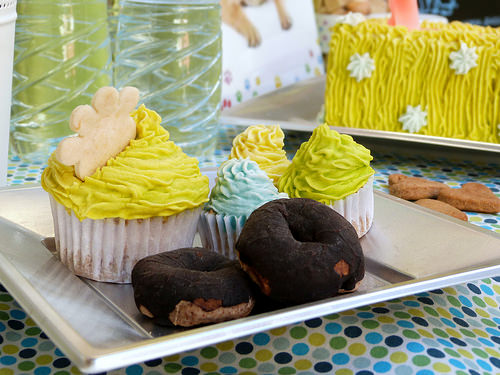<image>
Is there a food on the tray? No. The food is not positioned on the tray. They may be near each other, but the food is not supported by or resting on top of the tray. 